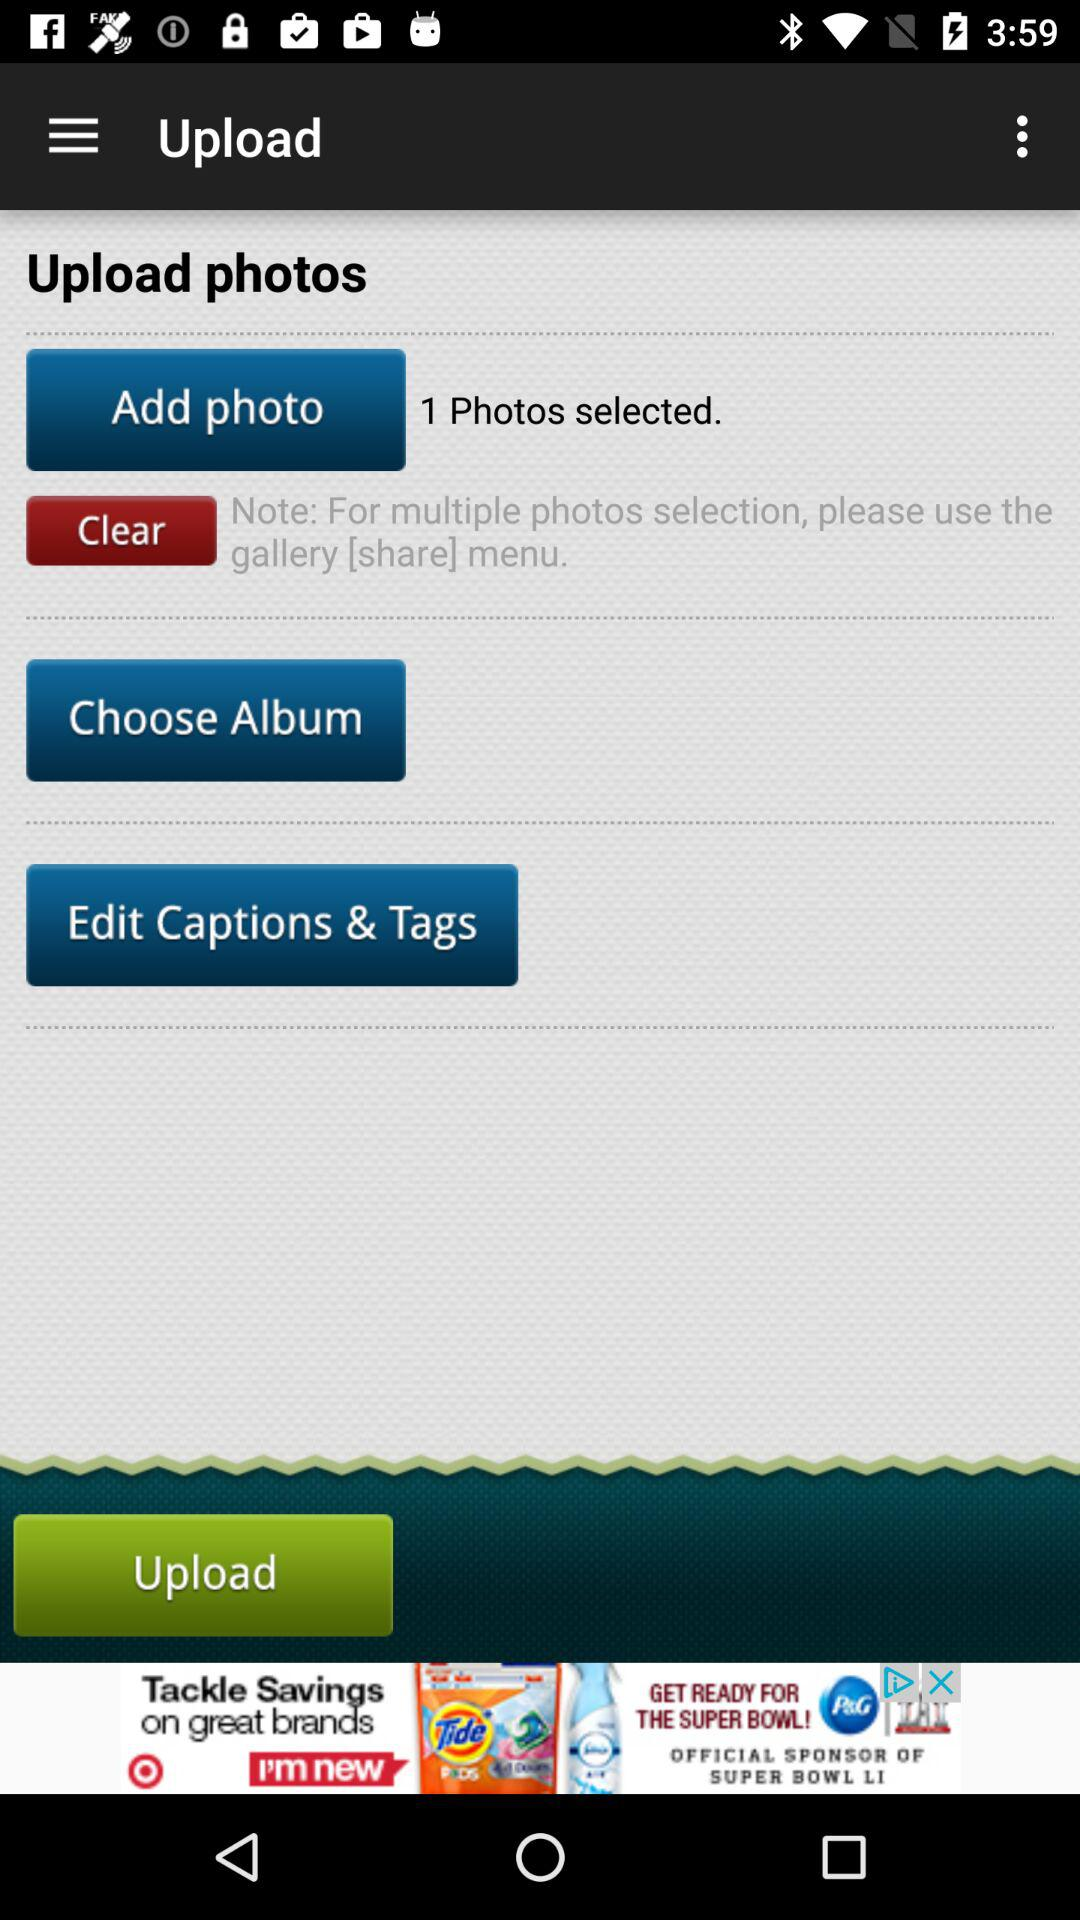What is the note? The note is "For multiple photos selection, please use the gallery [share] menu.". 